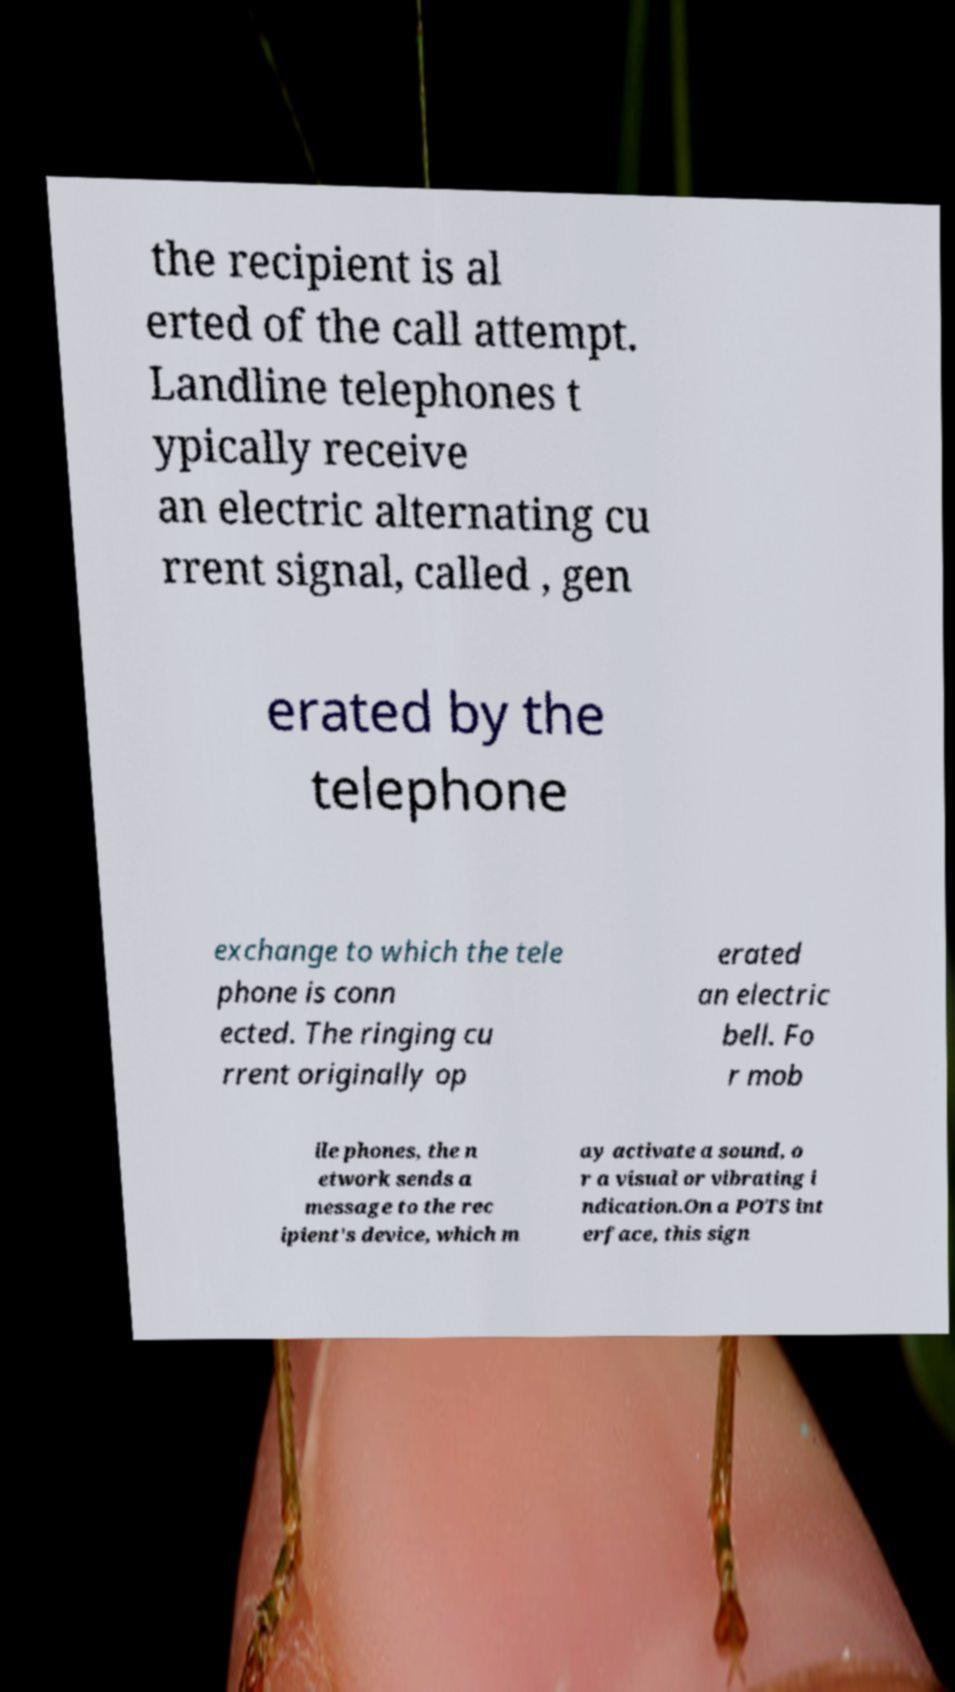Please read and relay the text visible in this image. What does it say? the recipient is al erted of the call attempt. Landline telephones t ypically receive an electric alternating cu rrent signal, called , gen erated by the telephone exchange to which the tele phone is conn ected. The ringing cu rrent originally op erated an electric bell. Fo r mob ile phones, the n etwork sends a message to the rec ipient's device, which m ay activate a sound, o r a visual or vibrating i ndication.On a POTS int erface, this sign 